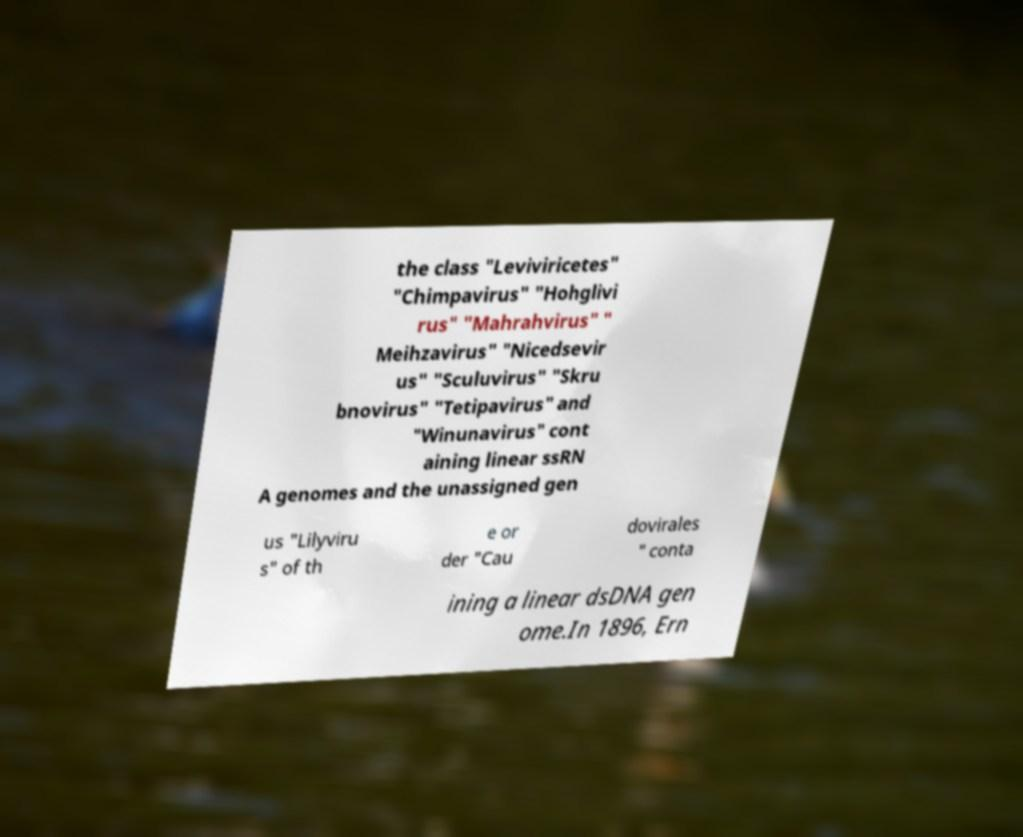Please read and relay the text visible in this image. What does it say? the class "Leviviricetes" "Chimpavirus" "Hohglivi rus" "Mahrahvirus" " Meihzavirus" "Nicedsevir us" "Sculuvirus" "Skru bnovirus" "Tetipavirus" and "Winunavirus" cont aining linear ssRN A genomes and the unassigned gen us "Lilyviru s" of th e or der "Cau dovirales " conta ining a linear dsDNA gen ome.In 1896, Ern 